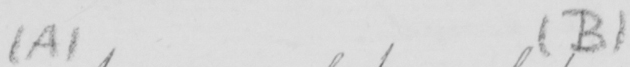Please transcribe the handwritten text in this image. ( A )   ( B ) 